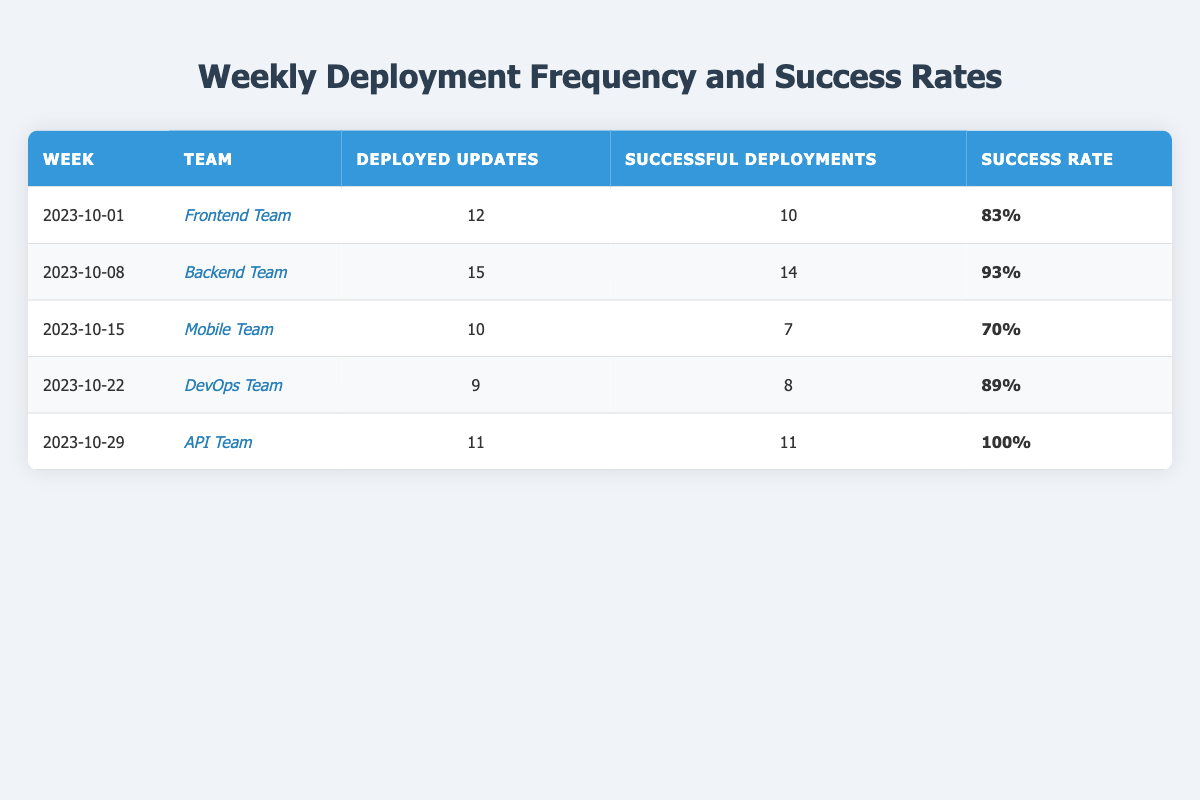What team had the highest success rate? By comparing the success rates for each team, the API Team had a success rate of 100%, which is the highest among all teams.
Answer: API Team How many total updates were deployed across all weeks? The total deployed updates can be calculated by summing the deployed updates for each week: 12 + 15 + 10 + 9 + 11 = 57.
Answer: 57 What was the success rate of the Mobile Team? The table shows that the Mobile Team had a success rate of 70%.
Answer: 70% Which team successfully deployed all their updates? Looking at the table, the API Team is the only team that successfully deployed all their updates, which is shown by having 11 successful deployments out of 11 total updates.
Answer: API Team What is the average success rate for all teams? To find the average success rate, convert each success rate to a decimal, sum them up (0.83 + 0.93 + 0.70 + 0.89 + 1.00 = 4.35), and divide by the number of teams (4.35 / 5 = 0.87). Converting back to a percentage gives an average success rate of 87%.
Answer: 87% Did the DevOps Team have a success rate higher than 80%? The success rate for the DevOps Team is 89%, which is indeed higher than 80%.
Answer: Yes What team had the fewest deployed updates? The team with the fewest deployed updates is the DevOps Team, which deployed 9 updates.
Answer: DevOps Team What is the difference in the number of deployed updates between the Backend Team and the Mobile Team? The Backend Team had 15 deployed updates while the Mobile Team had 10 updates. The difference is 15 - 10 = 5.
Answer: 5 Which week had the lowest total number of successful deployments? By reviewing the table, the week of 2023-10-15 corresponds to the Mobile Team, with only 7 successful deployments; this is the lowest.
Answer: 2023-10-15 What percentage of deployed updates were successful for the Frontend Team? The Frontend Team deployed 12 updates and had 10 successful deployments. To find the percentage, divide 10 by 12, resulting in 0.8333, which is 83%.
Answer: 83% 